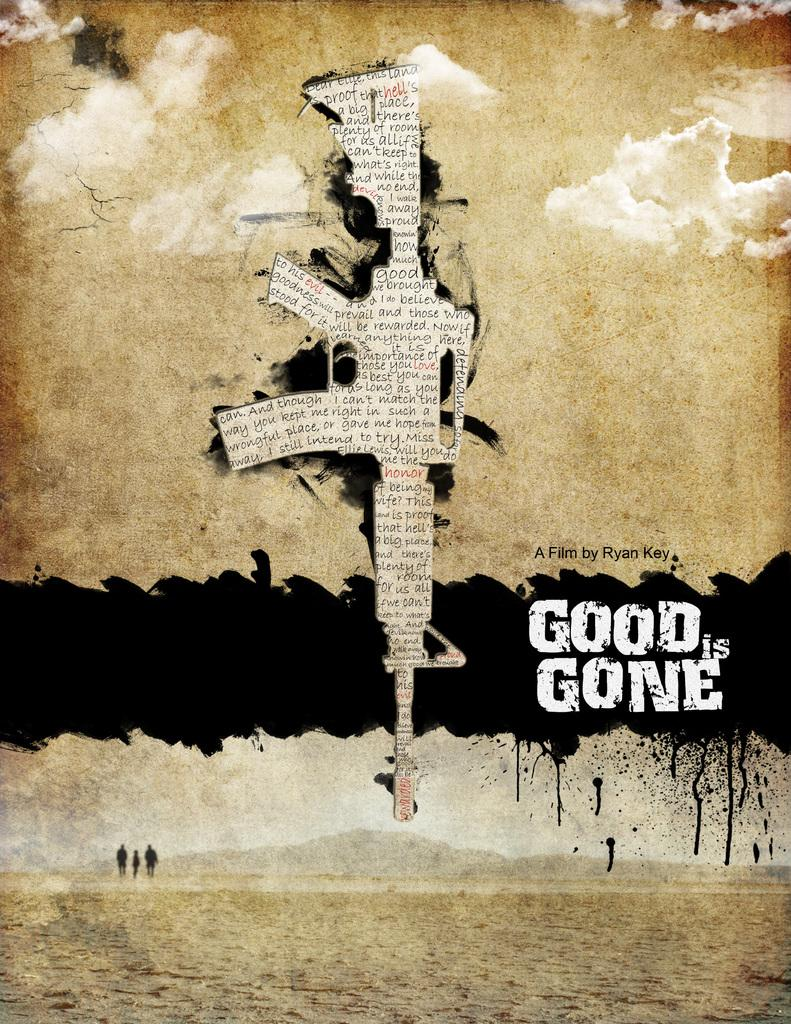<image>
Summarize the visual content of the image. A poster of the a film by Ryan Key with an image of a machine gun in the center of it. 